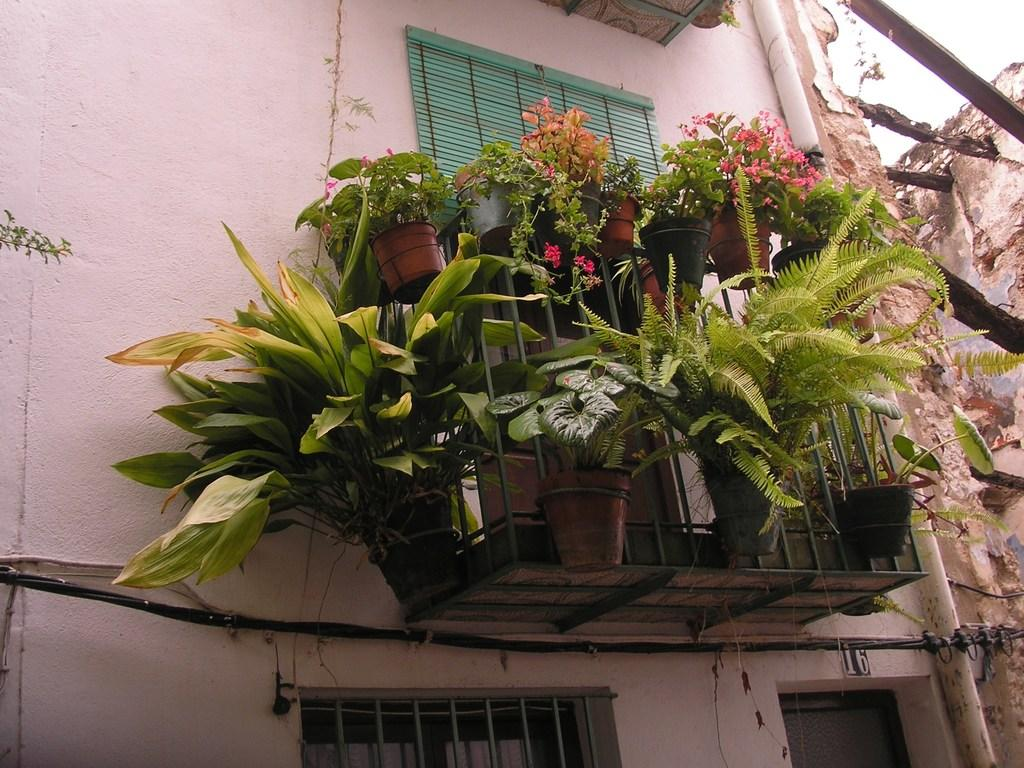What type of structure is visible in the image? There is a building in the image. What feature can be seen on the building? The building has windows. What is inside the windows? The windows have curtains. Are there any other elements attached to the building? Yes, there are pipes on the building. What can be found near the windows? There are stands attached to the wall near the windows. What is placed on the stands? The stands have pots with plants on them. What type of seed can be seen growing on the coal in the image? There is no coal or seed present in the image. 